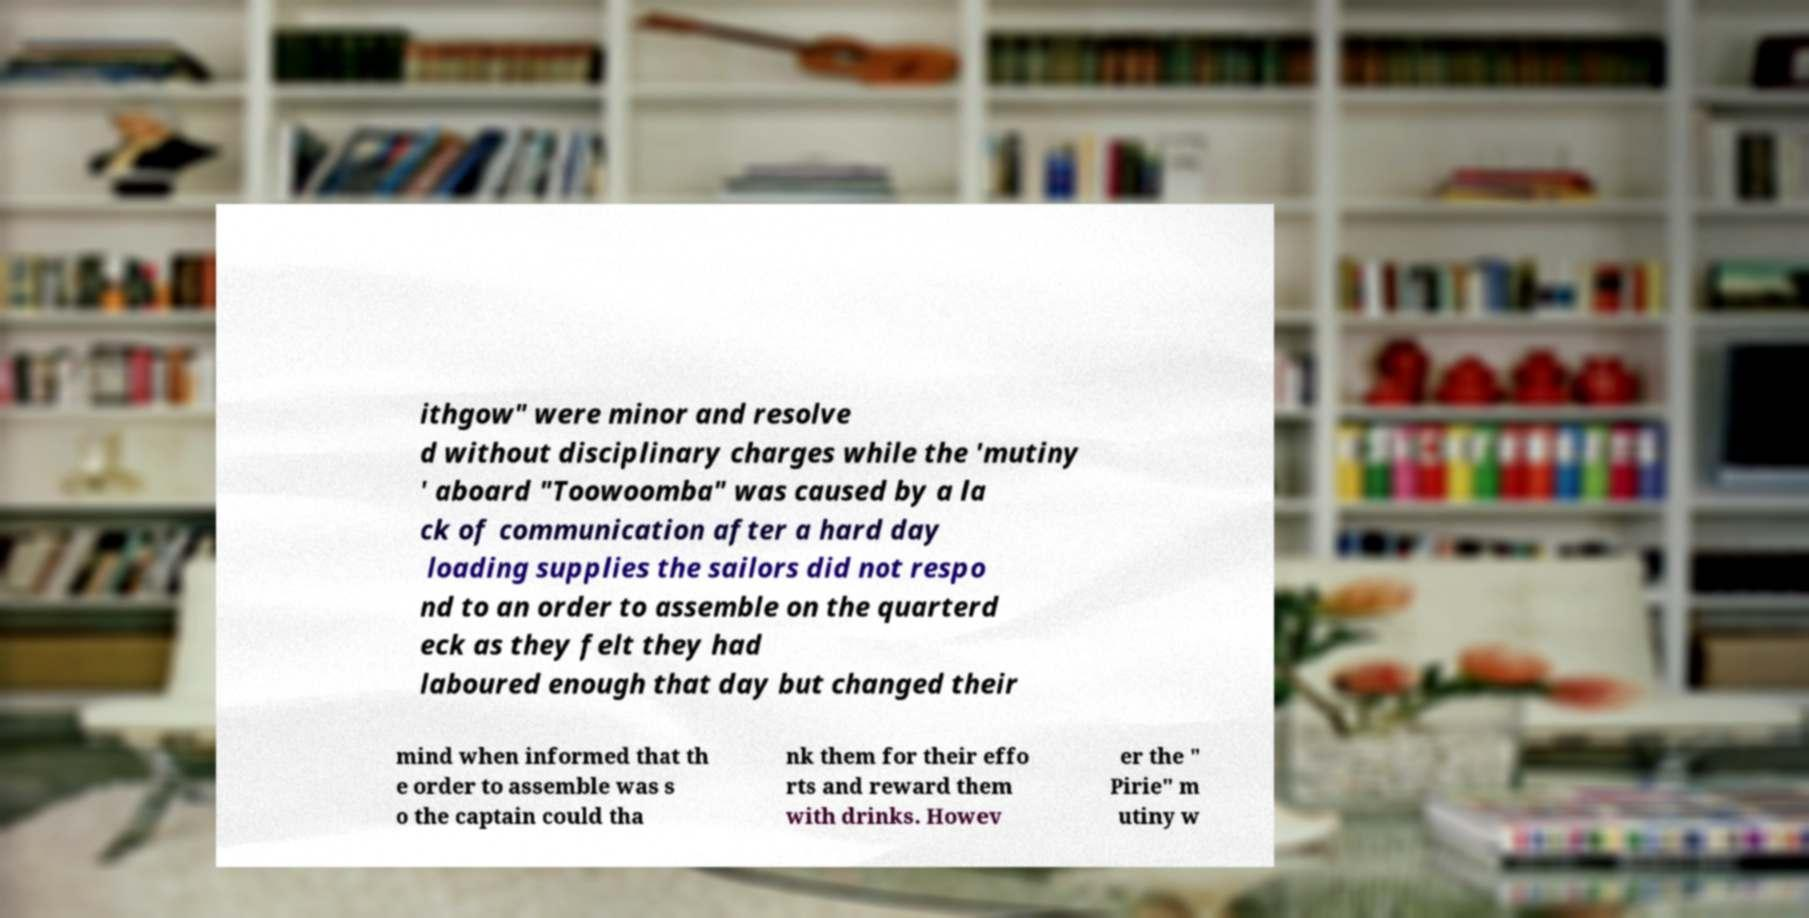What messages or text are displayed in this image? I need them in a readable, typed format. ithgow" were minor and resolve d without disciplinary charges while the 'mutiny ' aboard "Toowoomba" was caused by a la ck of communication after a hard day loading supplies the sailors did not respo nd to an order to assemble on the quarterd eck as they felt they had laboured enough that day but changed their mind when informed that th e order to assemble was s o the captain could tha nk them for their effo rts and reward them with drinks. Howev er the " Pirie" m utiny w 